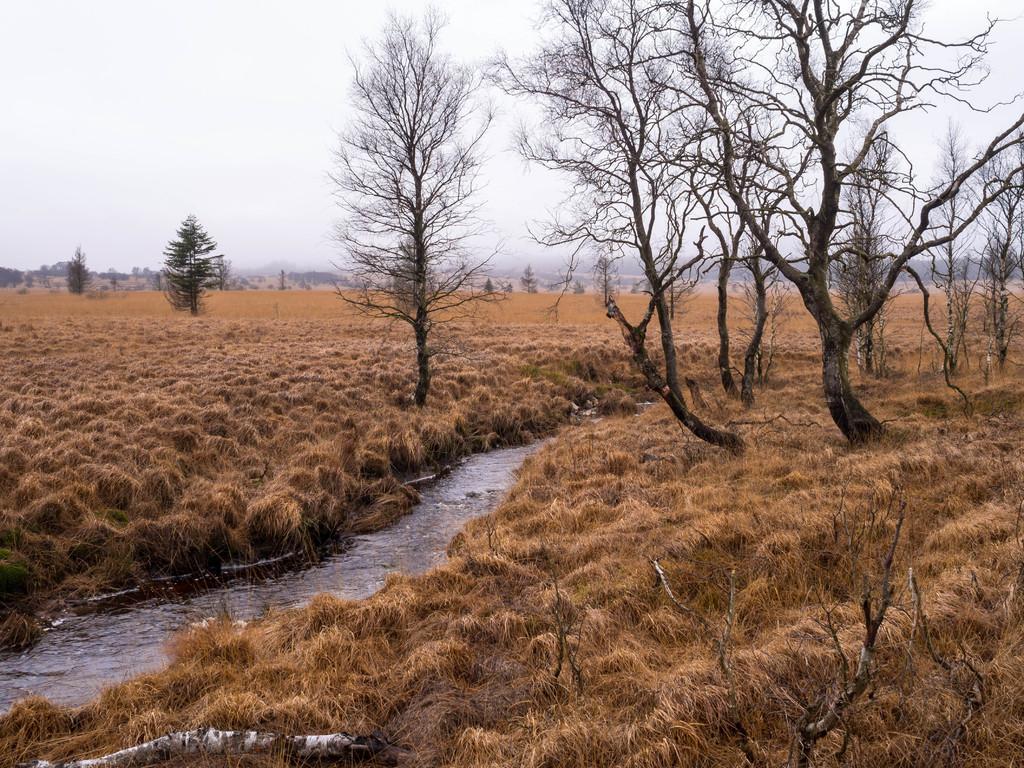Describe this image in one or two sentences. In this image, I can see water, dried grass and trees. In the background, there is the sky. 